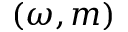<formula> <loc_0><loc_0><loc_500><loc_500>( \omega , m )</formula> 